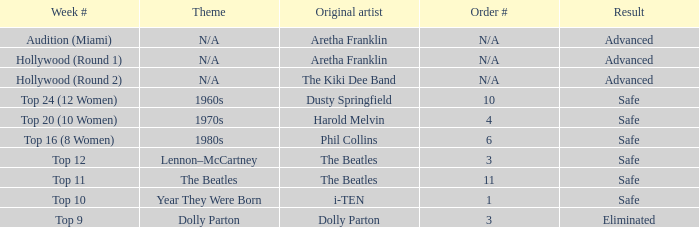What is the sequence number that has top 20 (10 women) as the week number? 4.0. 